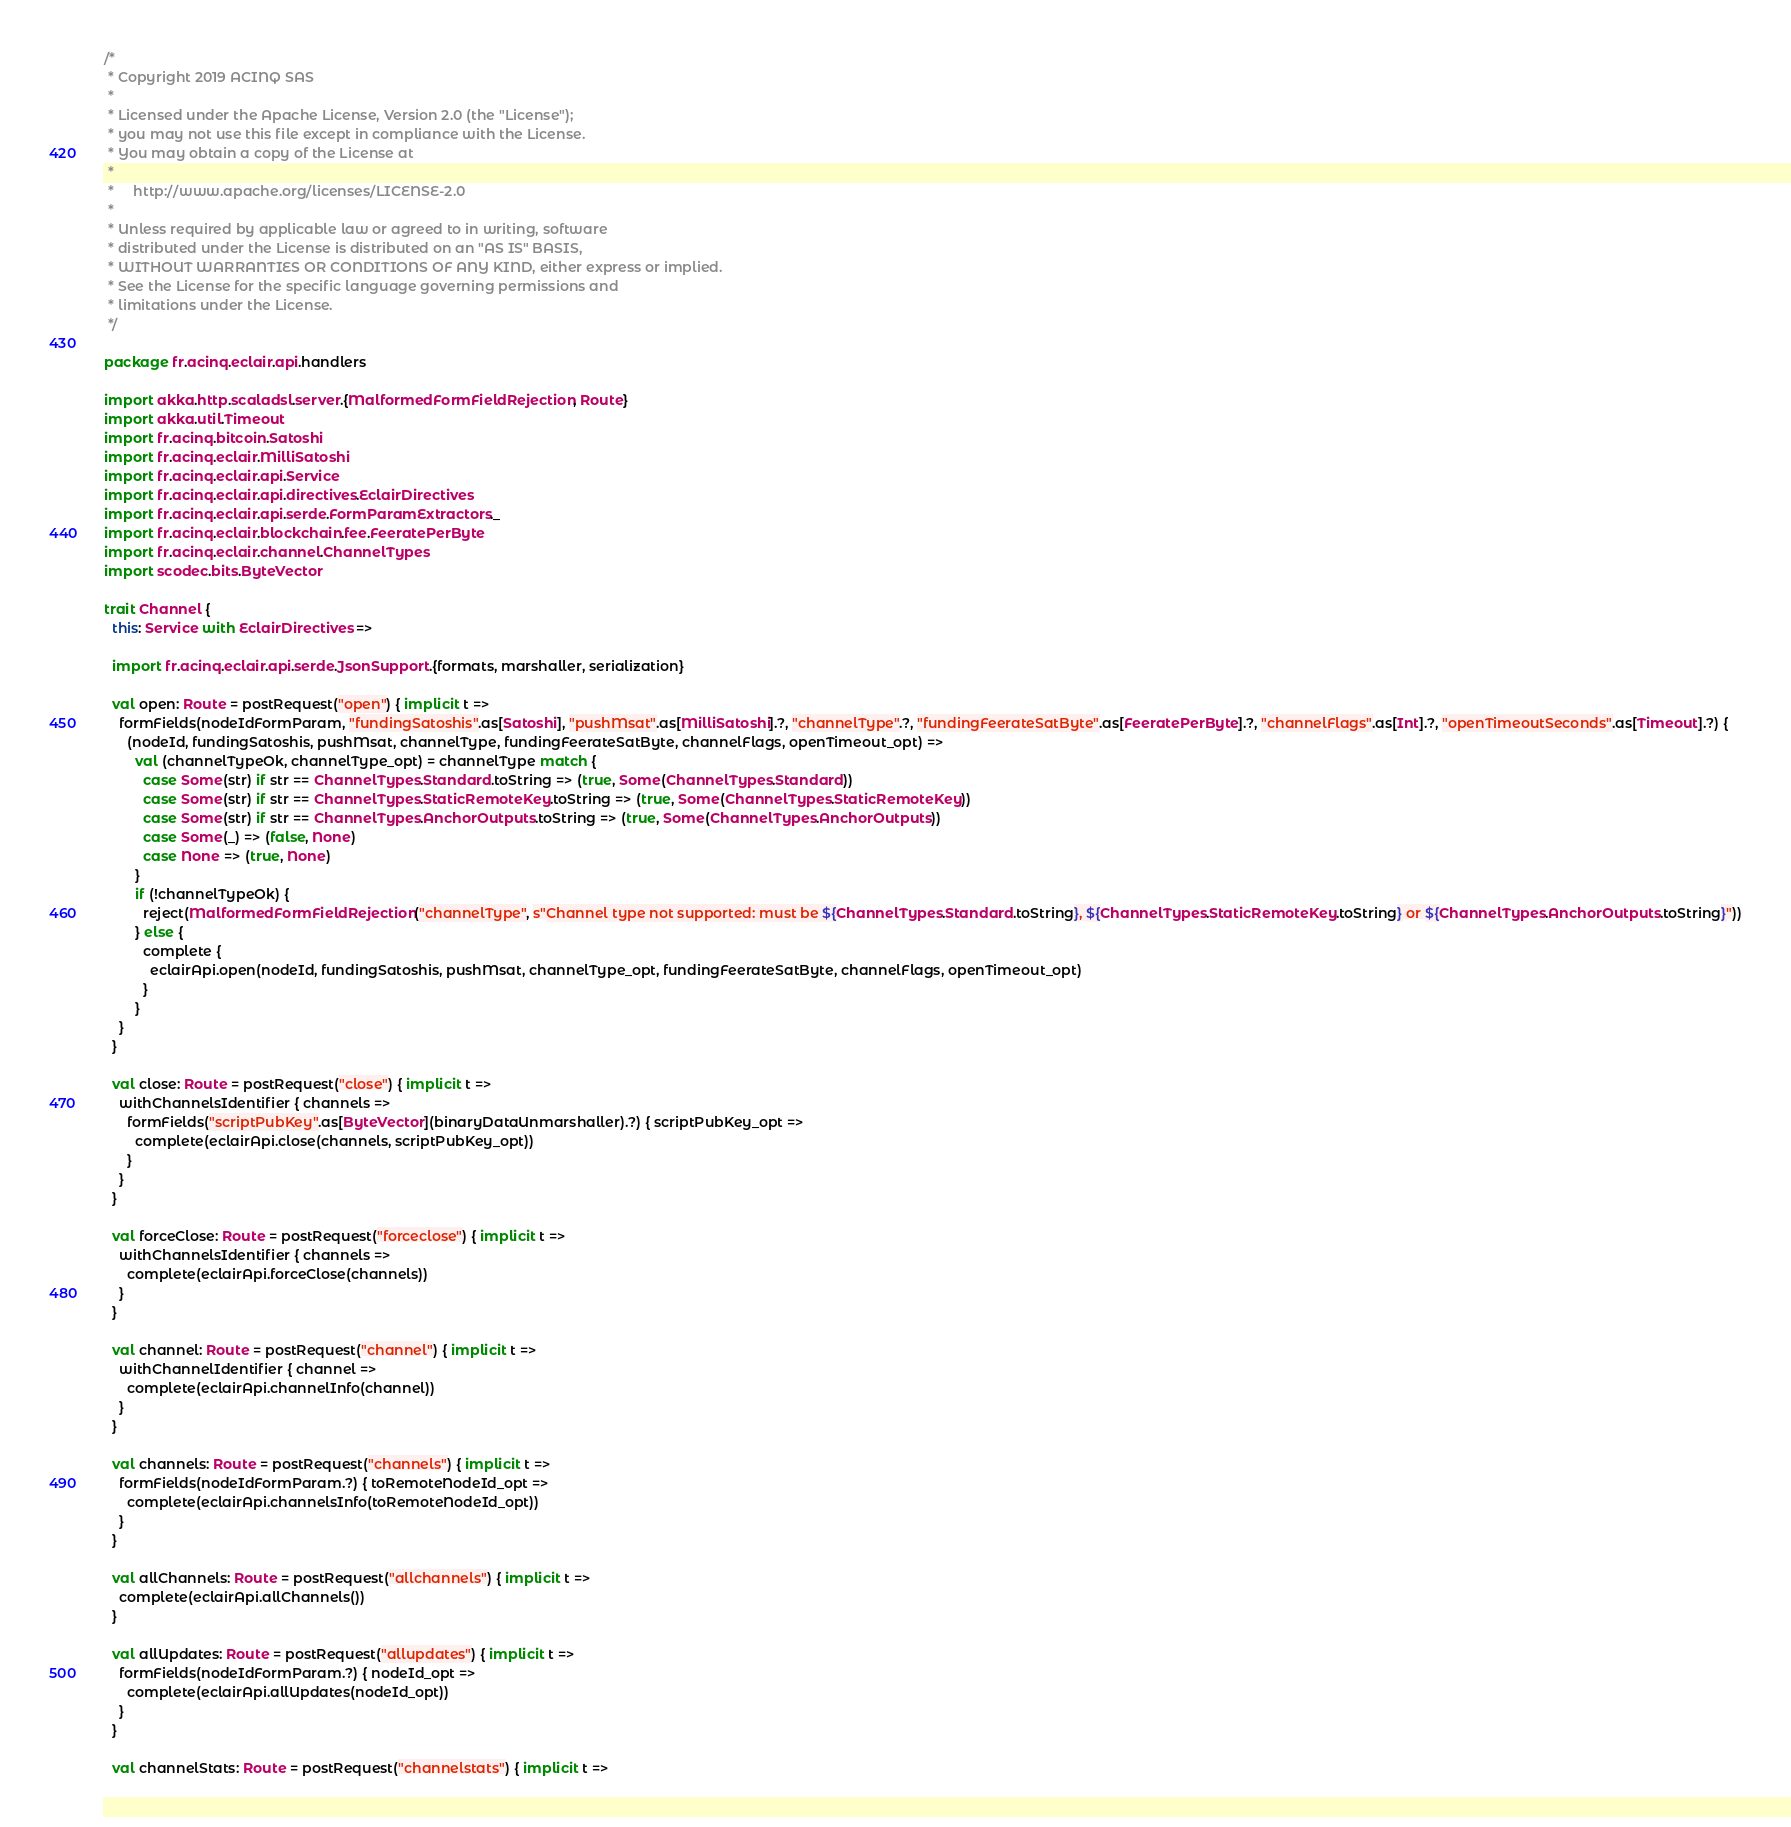Convert code to text. <code><loc_0><loc_0><loc_500><loc_500><_Scala_>/*
 * Copyright 2019 ACINQ SAS
 *
 * Licensed under the Apache License, Version 2.0 (the "License");
 * you may not use this file except in compliance with the License.
 * You may obtain a copy of the License at
 *
 *     http://www.apache.org/licenses/LICENSE-2.0
 *
 * Unless required by applicable law or agreed to in writing, software
 * distributed under the License is distributed on an "AS IS" BASIS,
 * WITHOUT WARRANTIES OR CONDITIONS OF ANY KIND, either express or implied.
 * See the License for the specific language governing permissions and
 * limitations under the License.
 */

package fr.acinq.eclair.api.handlers

import akka.http.scaladsl.server.{MalformedFormFieldRejection, Route}
import akka.util.Timeout
import fr.acinq.bitcoin.Satoshi
import fr.acinq.eclair.MilliSatoshi
import fr.acinq.eclair.api.Service
import fr.acinq.eclair.api.directives.EclairDirectives
import fr.acinq.eclair.api.serde.FormParamExtractors._
import fr.acinq.eclair.blockchain.fee.FeeratePerByte
import fr.acinq.eclair.channel.ChannelTypes
import scodec.bits.ByteVector

trait Channel {
  this: Service with EclairDirectives =>

  import fr.acinq.eclair.api.serde.JsonSupport.{formats, marshaller, serialization}

  val open: Route = postRequest("open") { implicit t =>
    formFields(nodeIdFormParam, "fundingSatoshis".as[Satoshi], "pushMsat".as[MilliSatoshi].?, "channelType".?, "fundingFeerateSatByte".as[FeeratePerByte].?, "channelFlags".as[Int].?, "openTimeoutSeconds".as[Timeout].?) {
      (nodeId, fundingSatoshis, pushMsat, channelType, fundingFeerateSatByte, channelFlags, openTimeout_opt) =>
        val (channelTypeOk, channelType_opt) = channelType match {
          case Some(str) if str == ChannelTypes.Standard.toString => (true, Some(ChannelTypes.Standard))
          case Some(str) if str == ChannelTypes.StaticRemoteKey.toString => (true, Some(ChannelTypes.StaticRemoteKey))
          case Some(str) if str == ChannelTypes.AnchorOutputs.toString => (true, Some(ChannelTypes.AnchorOutputs))
          case Some(_) => (false, None)
          case None => (true, None)
        }
        if (!channelTypeOk) {
          reject(MalformedFormFieldRejection("channelType", s"Channel type not supported: must be ${ChannelTypes.Standard.toString}, ${ChannelTypes.StaticRemoteKey.toString} or ${ChannelTypes.AnchorOutputs.toString}"))
        } else {
          complete {
            eclairApi.open(nodeId, fundingSatoshis, pushMsat, channelType_opt, fundingFeerateSatByte, channelFlags, openTimeout_opt)
          }
        }
    }
  }

  val close: Route = postRequest("close") { implicit t =>
    withChannelsIdentifier { channels =>
      formFields("scriptPubKey".as[ByteVector](binaryDataUnmarshaller).?) { scriptPubKey_opt =>
        complete(eclairApi.close(channels, scriptPubKey_opt))
      }
    }
  }

  val forceClose: Route = postRequest("forceclose") { implicit t =>
    withChannelsIdentifier { channels =>
      complete(eclairApi.forceClose(channels))
    }
  }

  val channel: Route = postRequest("channel") { implicit t =>
    withChannelIdentifier { channel =>
      complete(eclairApi.channelInfo(channel))
    }
  }

  val channels: Route = postRequest("channels") { implicit t =>
    formFields(nodeIdFormParam.?) { toRemoteNodeId_opt =>
      complete(eclairApi.channelsInfo(toRemoteNodeId_opt))
    }
  }

  val allChannels: Route = postRequest("allchannels") { implicit t =>
    complete(eclairApi.allChannels())
  }

  val allUpdates: Route = postRequest("allupdates") { implicit t =>
    formFields(nodeIdFormParam.?) { nodeId_opt =>
      complete(eclairApi.allUpdates(nodeId_opt))
    }
  }

  val channelStats: Route = postRequest("channelstats") { implicit t =></code> 